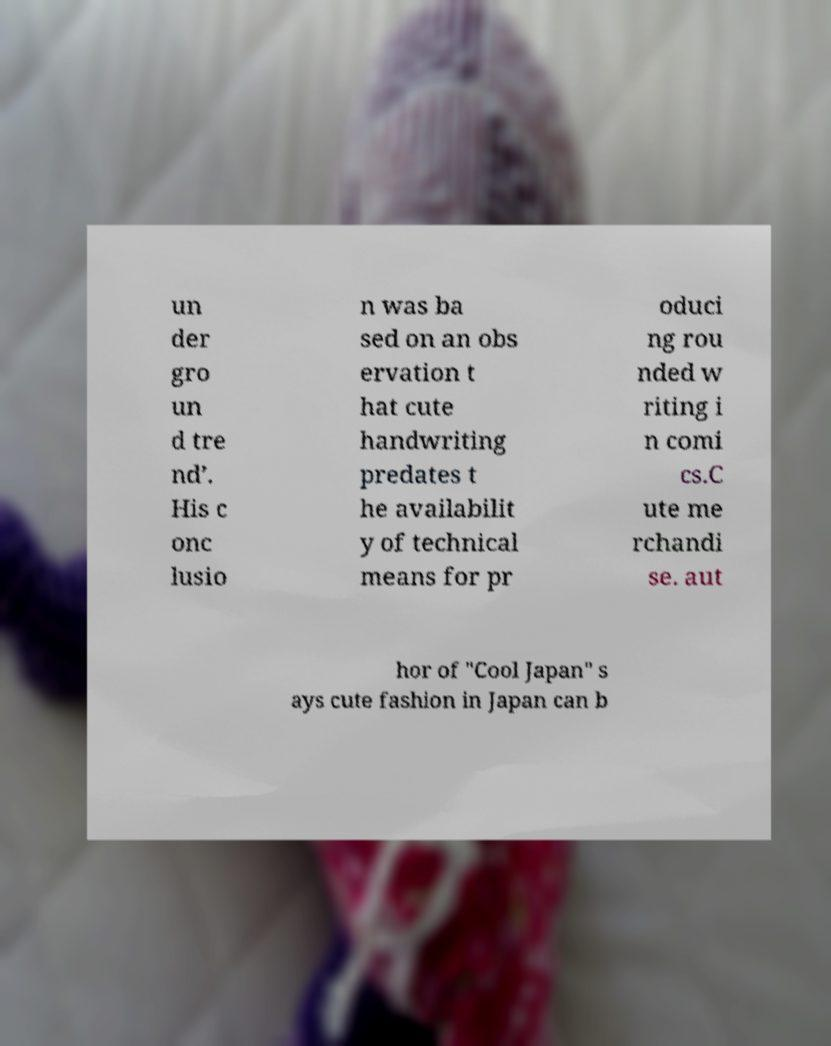Could you extract and type out the text from this image? un der gro un d tre nd’. His c onc lusio n was ba sed on an obs ervation t hat cute handwriting predates t he availabilit y of technical means for pr oduci ng rou nded w riting i n comi cs.C ute me rchandi se. aut hor of "Cool Japan" s ays cute fashion in Japan can b 